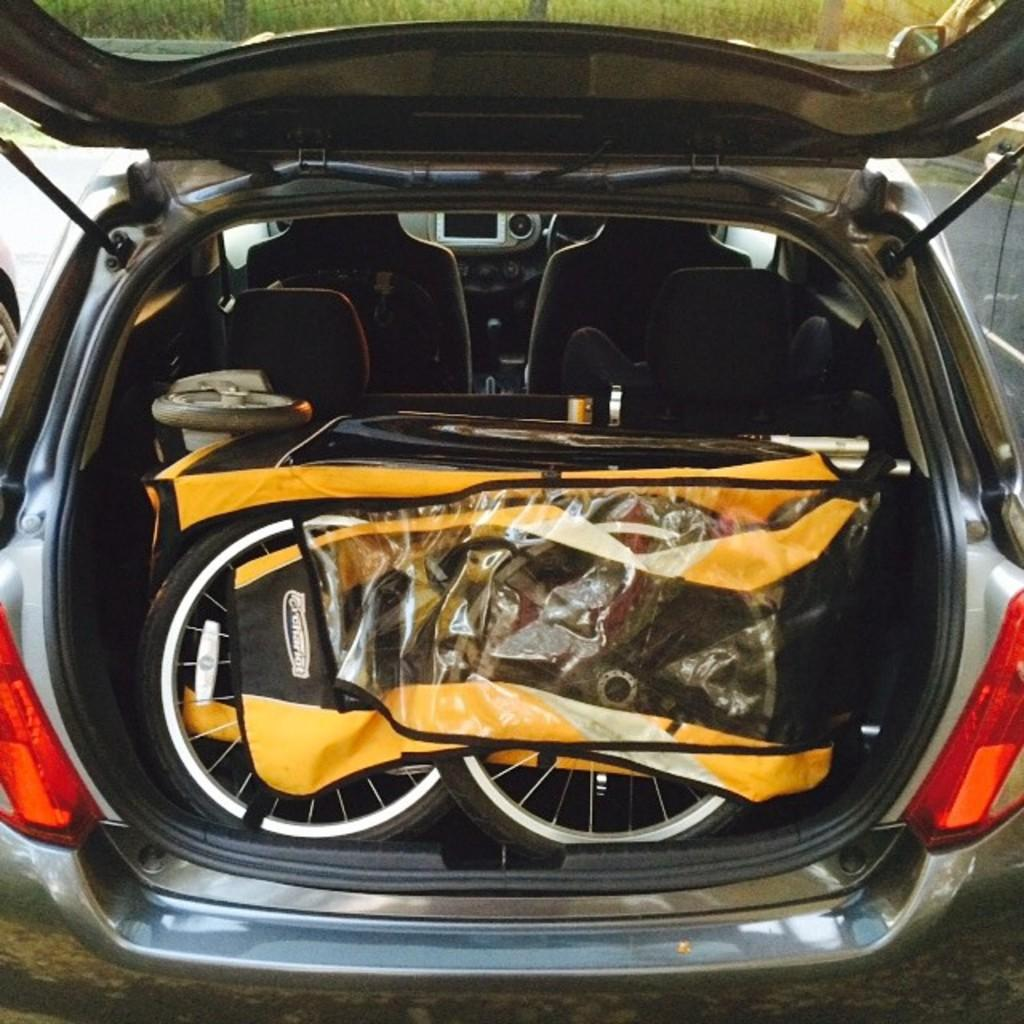What type of vehicle is shown in the image? The image shows the inside view of a car. What can be found inside the car? There are seats in the car. What is visible outside the car in the image? There are wheels in the image. What type of baseball equipment can be seen in the image? There is no baseball equipment present in the image; it shows the inside view of a car. What type of business is being conducted in the image? The image does not depict any business activities; it shows the inside view of a car. 